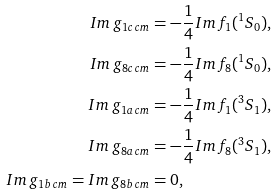Convert formula to latex. <formula><loc_0><loc_0><loc_500><loc_500>I m \, g _ { 1 c \, c m } & = - \frac { 1 } { 4 } I m \, f _ { 1 } ( ^ { 1 } S _ { 0 } ) , \\ I m \, g _ { 8 c \, c m } & = - \frac { 1 } { 4 } I m \, f _ { 8 } ( ^ { 1 } S _ { 0 } ) , \\ I m \, g _ { 1 a \, c m } & = - \frac { 1 } { 4 } I m \, f _ { 1 } ( ^ { 3 } S _ { 1 } ) , \\ I m \, g _ { 8 a \, c m } & = - \frac { 1 } { 4 } I m \, f _ { 8 } ( ^ { 3 } S _ { 1 } ) , \\ I m \, g _ { 1 b \, c m } = I m \, g _ { 8 b \, c m } & = 0 ,</formula> 